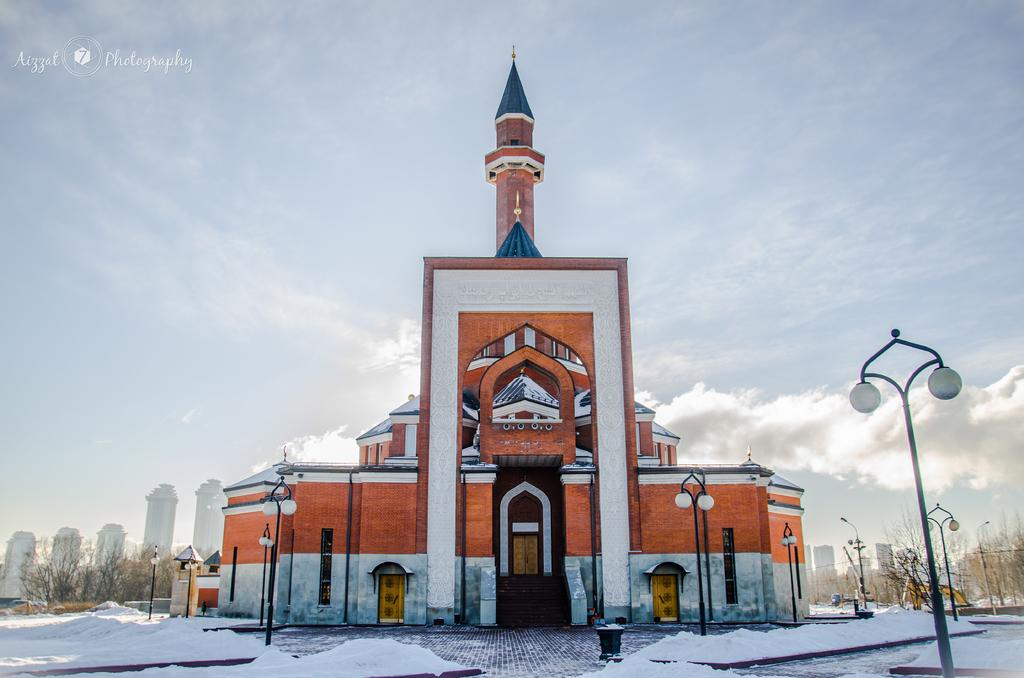What type of weather condition is depicted in the image? There is snow in the image, indicating a cold or wintry weather condition. What structures can be seen in the image? There are light poles, buildings, trees, and a tower visible in the image. What else can be seen in the image besides the structures? There are wires in the image. What is visible in the background of the image? The sky is visible in the image. Can you describe the lighting conditions in the image? The image may have been taken during a sunny day, as indicated by the presence of snow and the visibility of the sky. Can you tell me how many zebras are running across the snow in the image? There are no zebras present in the image; it features snow, structures, and wires. What type of motion can be seen in the image? The image does not depict any motion; it is a still image. 